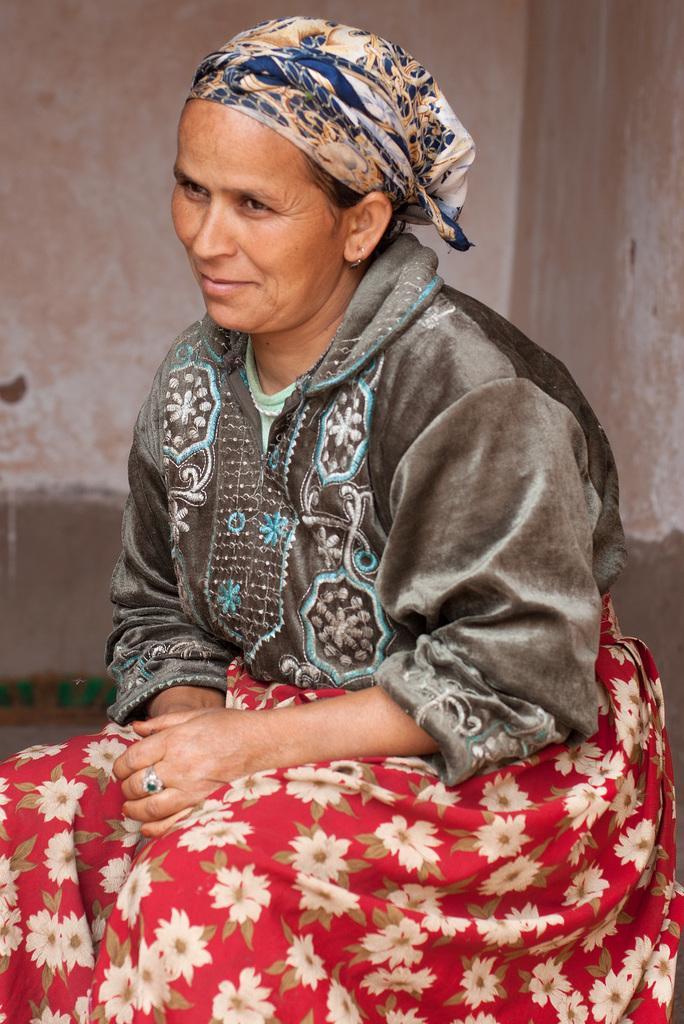Describe this image in one or two sentences. In the center of the image we can see a lady sitting. In the background there is a wall. 